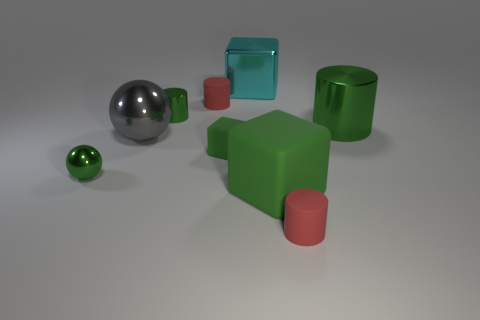Are there any tiny cylinders that have the same material as the cyan thing?
Give a very brief answer. Yes. There is another metal object that is the same shape as the large gray thing; what is its color?
Keep it short and to the point. Green. Is the material of the big cyan cube the same as the red cylinder that is behind the large gray metal ball?
Make the answer very short. No. The red thing that is behind the green shiny cylinder behind the big green metallic thing is what shape?
Keep it short and to the point. Cylinder. There is a green shiny object that is on the right side of the cyan cube; does it have the same size as the gray ball?
Keep it short and to the point. Yes. What number of other things are the same shape as the large cyan thing?
Provide a short and direct response. 2. There is a tiny rubber thing in front of the tiny sphere; does it have the same color as the big rubber object?
Provide a short and direct response. No. Are there any small metal objects that have the same color as the tiny rubber cube?
Ensure brevity in your answer.  Yes. There is a gray object; how many shiny objects are behind it?
Your answer should be compact. 3. How many other objects are the same size as the green metallic ball?
Offer a terse response. 4. 